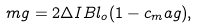<formula> <loc_0><loc_0><loc_500><loc_500>m g = 2 \Delta I B l _ { o } ( 1 - c _ { m } a g ) ,</formula> 